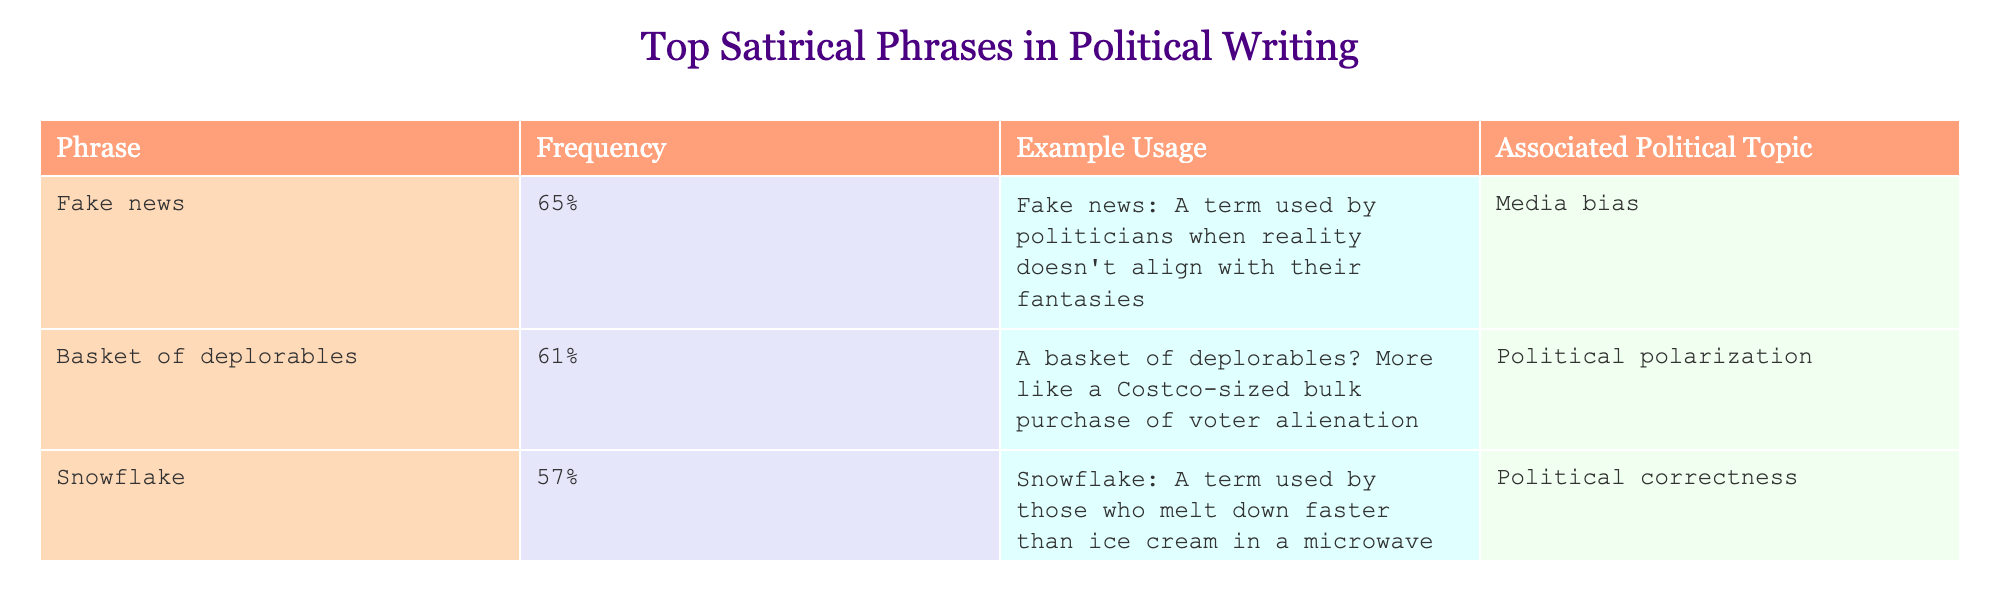What is the phrase with the highest frequency? The phrase with the highest frequency can be found in the "Frequency" column. By looking through the values, "Fake news" has the highest percentage at 65%.
Answer: Fake news Which political topic is associated with the phrase "Basket of deplorables"? The "Associated Political Topic" column shows the topic related to each phrase. For "Basket of deplorables," the associated topic is "Political polarization."
Answer: Political polarization What is the average frequency of the phrases listed in the table? To find the average, sum the frequencies of all phrases: 65% + 61% + 57% + 54% = 237%. There are 4 phrases, so divide the total by 4: 237% / 4 = 59.25%.
Answer: 59.25% Is "Snowflake" used more frequently than "Make X Great Again"? Comparing the frequencies of both phrases, "Snowflake" has a frequency of 57%, while "Make X Great Again" has 54%. Since 57% is greater than 54%, the answer is yes.
Answer: Yes Which phrase is associated with the highest frequency and what is its example usage? Referring to the table, "Fake news" has the highest frequency of 65%. Its example usage is "Fake news: A term used by politicians when reality doesn't align with their fantasies."
Answer: Fake news; Fake news: A term used by politicians when reality doesn't align with their fantasies 